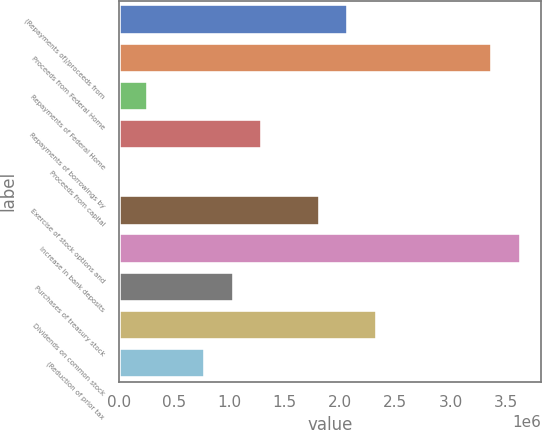Convert chart. <chart><loc_0><loc_0><loc_500><loc_500><bar_chart><fcel>(Repayments of)/proceeds from<fcel>Proceeds from Federal Home<fcel>Repayments of Federal Home<fcel>Repayments of borrowings by<fcel>Proceeds from capital<fcel>Exercise of stock options and<fcel>Increase in bank deposits<fcel>Purchases of treasury stock<fcel>Dividends on common stock<fcel>(Reduction of prior tax<nl><fcel>2.07744e+06<fcel>3.37538e+06<fcel>260315<fcel>1.29867e+06<fcel>726<fcel>1.81785e+06<fcel>3.63497e+06<fcel>1.03908e+06<fcel>2.33703e+06<fcel>779493<nl></chart> 